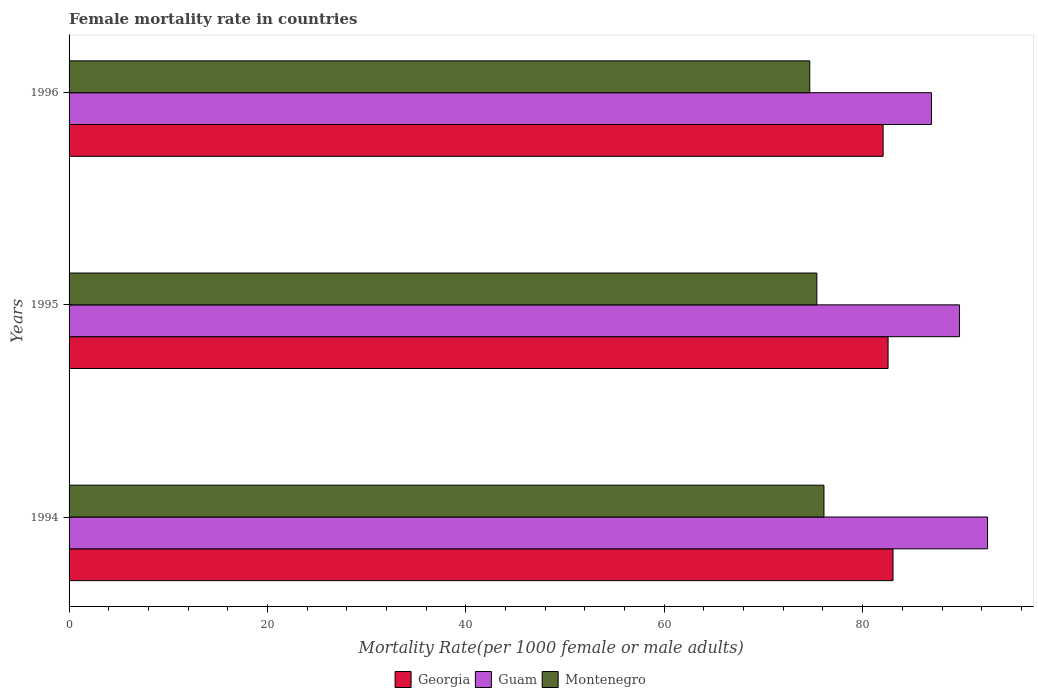How many groups of bars are there?
Your answer should be compact. 3. Are the number of bars on each tick of the Y-axis equal?
Make the answer very short. Yes. How many bars are there on the 1st tick from the top?
Your answer should be very brief. 3. How many bars are there on the 3rd tick from the bottom?
Give a very brief answer. 3. In how many cases, is the number of bars for a given year not equal to the number of legend labels?
Keep it short and to the point. 0. What is the female mortality rate in Montenegro in 1994?
Provide a succinct answer. 76.1. Across all years, what is the maximum female mortality rate in Georgia?
Provide a short and direct response. 83.06. Across all years, what is the minimum female mortality rate in Guam?
Keep it short and to the point. 86.94. What is the total female mortality rate in Montenegro in the graph?
Offer a terse response. 226.15. What is the difference between the female mortality rate in Montenegro in 1994 and that in 1996?
Offer a terse response. 1.43. What is the difference between the female mortality rate in Guam in 1994 and the female mortality rate in Georgia in 1995?
Offer a terse response. 10.03. What is the average female mortality rate in Montenegro per year?
Offer a terse response. 75.38. In the year 1996, what is the difference between the female mortality rate in Georgia and female mortality rate in Guam?
Offer a terse response. -4.87. What is the ratio of the female mortality rate in Guam in 1995 to that in 1996?
Your answer should be compact. 1.03. Is the female mortality rate in Guam in 1995 less than that in 1996?
Keep it short and to the point. No. What is the difference between the highest and the second highest female mortality rate in Montenegro?
Provide a succinct answer. 0.72. What is the difference between the highest and the lowest female mortality rate in Guam?
Provide a short and direct response. 5.66. Is the sum of the female mortality rate in Guam in 1994 and 1995 greater than the maximum female mortality rate in Montenegro across all years?
Make the answer very short. Yes. What does the 2nd bar from the top in 1994 represents?
Ensure brevity in your answer.  Guam. What does the 2nd bar from the bottom in 1994 represents?
Your response must be concise. Guam. Is it the case that in every year, the sum of the female mortality rate in Guam and female mortality rate in Montenegro is greater than the female mortality rate in Georgia?
Give a very brief answer. Yes. What is the difference between two consecutive major ticks on the X-axis?
Your answer should be compact. 20. Are the values on the major ticks of X-axis written in scientific E-notation?
Make the answer very short. No. Does the graph contain any zero values?
Offer a very short reply. No. Where does the legend appear in the graph?
Provide a succinct answer. Bottom center. How many legend labels are there?
Ensure brevity in your answer.  3. What is the title of the graph?
Your response must be concise. Female mortality rate in countries. Does "Thailand" appear as one of the legend labels in the graph?
Your answer should be very brief. No. What is the label or title of the X-axis?
Keep it short and to the point. Mortality Rate(per 1000 female or male adults). What is the label or title of the Y-axis?
Provide a succinct answer. Years. What is the Mortality Rate(per 1000 female or male adults) of Georgia in 1994?
Offer a very short reply. 83.06. What is the Mortality Rate(per 1000 female or male adults) in Guam in 1994?
Offer a very short reply. 92.59. What is the Mortality Rate(per 1000 female or male adults) in Montenegro in 1994?
Your response must be concise. 76.1. What is the Mortality Rate(per 1000 female or male adults) in Georgia in 1995?
Your response must be concise. 82.56. What is the Mortality Rate(per 1000 female or male adults) in Guam in 1995?
Offer a very short reply. 89.77. What is the Mortality Rate(per 1000 female or male adults) of Montenegro in 1995?
Your answer should be compact. 75.38. What is the Mortality Rate(per 1000 female or male adults) in Georgia in 1996?
Offer a terse response. 82.06. What is the Mortality Rate(per 1000 female or male adults) in Guam in 1996?
Provide a succinct answer. 86.94. What is the Mortality Rate(per 1000 female or male adults) of Montenegro in 1996?
Your answer should be very brief. 74.67. Across all years, what is the maximum Mortality Rate(per 1000 female or male adults) in Georgia?
Your answer should be compact. 83.06. Across all years, what is the maximum Mortality Rate(per 1000 female or male adults) in Guam?
Make the answer very short. 92.59. Across all years, what is the maximum Mortality Rate(per 1000 female or male adults) of Montenegro?
Ensure brevity in your answer.  76.1. Across all years, what is the minimum Mortality Rate(per 1000 female or male adults) of Georgia?
Provide a succinct answer. 82.06. Across all years, what is the minimum Mortality Rate(per 1000 female or male adults) in Guam?
Provide a short and direct response. 86.94. Across all years, what is the minimum Mortality Rate(per 1000 female or male adults) in Montenegro?
Give a very brief answer. 74.67. What is the total Mortality Rate(per 1000 female or male adults) in Georgia in the graph?
Keep it short and to the point. 247.69. What is the total Mortality Rate(per 1000 female or male adults) in Guam in the graph?
Offer a terse response. 269.29. What is the total Mortality Rate(per 1000 female or male adults) of Montenegro in the graph?
Keep it short and to the point. 226.15. What is the difference between the Mortality Rate(per 1000 female or male adults) of Georgia in 1994 and that in 1995?
Your answer should be very brief. 0.5. What is the difference between the Mortality Rate(per 1000 female or male adults) in Guam in 1994 and that in 1995?
Your response must be concise. 2.83. What is the difference between the Mortality Rate(per 1000 female or male adults) in Montenegro in 1994 and that in 1995?
Offer a terse response. 0.72. What is the difference between the Mortality Rate(per 1000 female or male adults) in Georgia in 1994 and that in 1996?
Your answer should be very brief. 1. What is the difference between the Mortality Rate(per 1000 female or male adults) in Guam in 1994 and that in 1996?
Give a very brief answer. 5.66. What is the difference between the Mortality Rate(per 1000 female or male adults) in Montenegro in 1994 and that in 1996?
Your response must be concise. 1.43. What is the difference between the Mortality Rate(per 1000 female or male adults) in Georgia in 1995 and that in 1996?
Offer a terse response. 0.5. What is the difference between the Mortality Rate(per 1000 female or male adults) in Guam in 1995 and that in 1996?
Make the answer very short. 2.83. What is the difference between the Mortality Rate(per 1000 female or male adults) of Montenegro in 1995 and that in 1996?
Offer a very short reply. 0.72. What is the difference between the Mortality Rate(per 1000 female or male adults) of Georgia in 1994 and the Mortality Rate(per 1000 female or male adults) of Guam in 1995?
Provide a short and direct response. -6.7. What is the difference between the Mortality Rate(per 1000 female or male adults) of Georgia in 1994 and the Mortality Rate(per 1000 female or male adults) of Montenegro in 1995?
Provide a succinct answer. 7.68. What is the difference between the Mortality Rate(per 1000 female or male adults) in Guam in 1994 and the Mortality Rate(per 1000 female or male adults) in Montenegro in 1995?
Your answer should be very brief. 17.21. What is the difference between the Mortality Rate(per 1000 female or male adults) of Georgia in 1994 and the Mortality Rate(per 1000 female or male adults) of Guam in 1996?
Keep it short and to the point. -3.87. What is the difference between the Mortality Rate(per 1000 female or male adults) of Georgia in 1994 and the Mortality Rate(per 1000 female or male adults) of Montenegro in 1996?
Give a very brief answer. 8.39. What is the difference between the Mortality Rate(per 1000 female or male adults) of Guam in 1994 and the Mortality Rate(per 1000 female or male adults) of Montenegro in 1996?
Give a very brief answer. 17.93. What is the difference between the Mortality Rate(per 1000 female or male adults) in Georgia in 1995 and the Mortality Rate(per 1000 female or male adults) in Guam in 1996?
Provide a short and direct response. -4.37. What is the difference between the Mortality Rate(per 1000 female or male adults) in Georgia in 1995 and the Mortality Rate(per 1000 female or male adults) in Montenegro in 1996?
Ensure brevity in your answer.  7.9. What is the difference between the Mortality Rate(per 1000 female or male adults) of Guam in 1995 and the Mortality Rate(per 1000 female or male adults) of Montenegro in 1996?
Provide a short and direct response. 15.1. What is the average Mortality Rate(per 1000 female or male adults) in Georgia per year?
Keep it short and to the point. 82.56. What is the average Mortality Rate(per 1000 female or male adults) of Guam per year?
Offer a very short reply. 89.76. What is the average Mortality Rate(per 1000 female or male adults) in Montenegro per year?
Ensure brevity in your answer.  75.38. In the year 1994, what is the difference between the Mortality Rate(per 1000 female or male adults) of Georgia and Mortality Rate(per 1000 female or male adults) of Guam?
Provide a short and direct response. -9.53. In the year 1994, what is the difference between the Mortality Rate(per 1000 female or male adults) of Georgia and Mortality Rate(per 1000 female or male adults) of Montenegro?
Provide a succinct answer. 6.96. In the year 1994, what is the difference between the Mortality Rate(per 1000 female or male adults) in Guam and Mortality Rate(per 1000 female or male adults) in Montenegro?
Offer a very short reply. 16.49. In the year 1995, what is the difference between the Mortality Rate(per 1000 female or male adults) in Georgia and Mortality Rate(per 1000 female or male adults) in Guam?
Ensure brevity in your answer.  -7.2. In the year 1995, what is the difference between the Mortality Rate(per 1000 female or male adults) of Georgia and Mortality Rate(per 1000 female or male adults) of Montenegro?
Give a very brief answer. 7.18. In the year 1995, what is the difference between the Mortality Rate(per 1000 female or male adults) in Guam and Mortality Rate(per 1000 female or male adults) in Montenegro?
Offer a terse response. 14.38. In the year 1996, what is the difference between the Mortality Rate(per 1000 female or male adults) in Georgia and Mortality Rate(per 1000 female or male adults) in Guam?
Offer a terse response. -4.87. In the year 1996, what is the difference between the Mortality Rate(per 1000 female or male adults) of Georgia and Mortality Rate(per 1000 female or male adults) of Montenegro?
Keep it short and to the point. 7.4. In the year 1996, what is the difference between the Mortality Rate(per 1000 female or male adults) of Guam and Mortality Rate(per 1000 female or male adults) of Montenegro?
Make the answer very short. 12.27. What is the ratio of the Mortality Rate(per 1000 female or male adults) of Guam in 1994 to that in 1995?
Your answer should be compact. 1.03. What is the ratio of the Mortality Rate(per 1000 female or male adults) of Montenegro in 1994 to that in 1995?
Make the answer very short. 1.01. What is the ratio of the Mortality Rate(per 1000 female or male adults) in Georgia in 1994 to that in 1996?
Make the answer very short. 1.01. What is the ratio of the Mortality Rate(per 1000 female or male adults) of Guam in 1994 to that in 1996?
Give a very brief answer. 1.07. What is the ratio of the Mortality Rate(per 1000 female or male adults) of Montenegro in 1994 to that in 1996?
Ensure brevity in your answer.  1.02. What is the ratio of the Mortality Rate(per 1000 female or male adults) in Guam in 1995 to that in 1996?
Ensure brevity in your answer.  1.03. What is the ratio of the Mortality Rate(per 1000 female or male adults) of Montenegro in 1995 to that in 1996?
Provide a succinct answer. 1.01. What is the difference between the highest and the second highest Mortality Rate(per 1000 female or male adults) in Georgia?
Your answer should be compact. 0.5. What is the difference between the highest and the second highest Mortality Rate(per 1000 female or male adults) of Guam?
Offer a very short reply. 2.83. What is the difference between the highest and the second highest Mortality Rate(per 1000 female or male adults) in Montenegro?
Offer a terse response. 0.72. What is the difference between the highest and the lowest Mortality Rate(per 1000 female or male adults) of Georgia?
Provide a short and direct response. 1. What is the difference between the highest and the lowest Mortality Rate(per 1000 female or male adults) of Guam?
Your answer should be compact. 5.66. What is the difference between the highest and the lowest Mortality Rate(per 1000 female or male adults) in Montenegro?
Offer a very short reply. 1.43. 